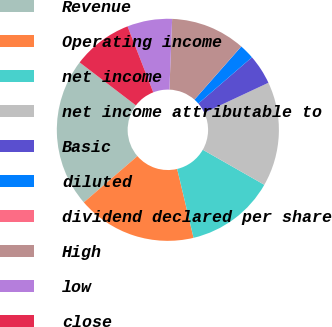Convert chart to OTSL. <chart><loc_0><loc_0><loc_500><loc_500><pie_chart><fcel>Revenue<fcel>Operating income<fcel>net income<fcel>net income attributable to<fcel>Basic<fcel>diluted<fcel>dividend declared per share<fcel>High<fcel>low<fcel>close<nl><fcel>21.72%<fcel>17.38%<fcel>13.04%<fcel>15.21%<fcel>4.36%<fcel>2.18%<fcel>0.01%<fcel>10.87%<fcel>6.53%<fcel>8.7%<nl></chart> 